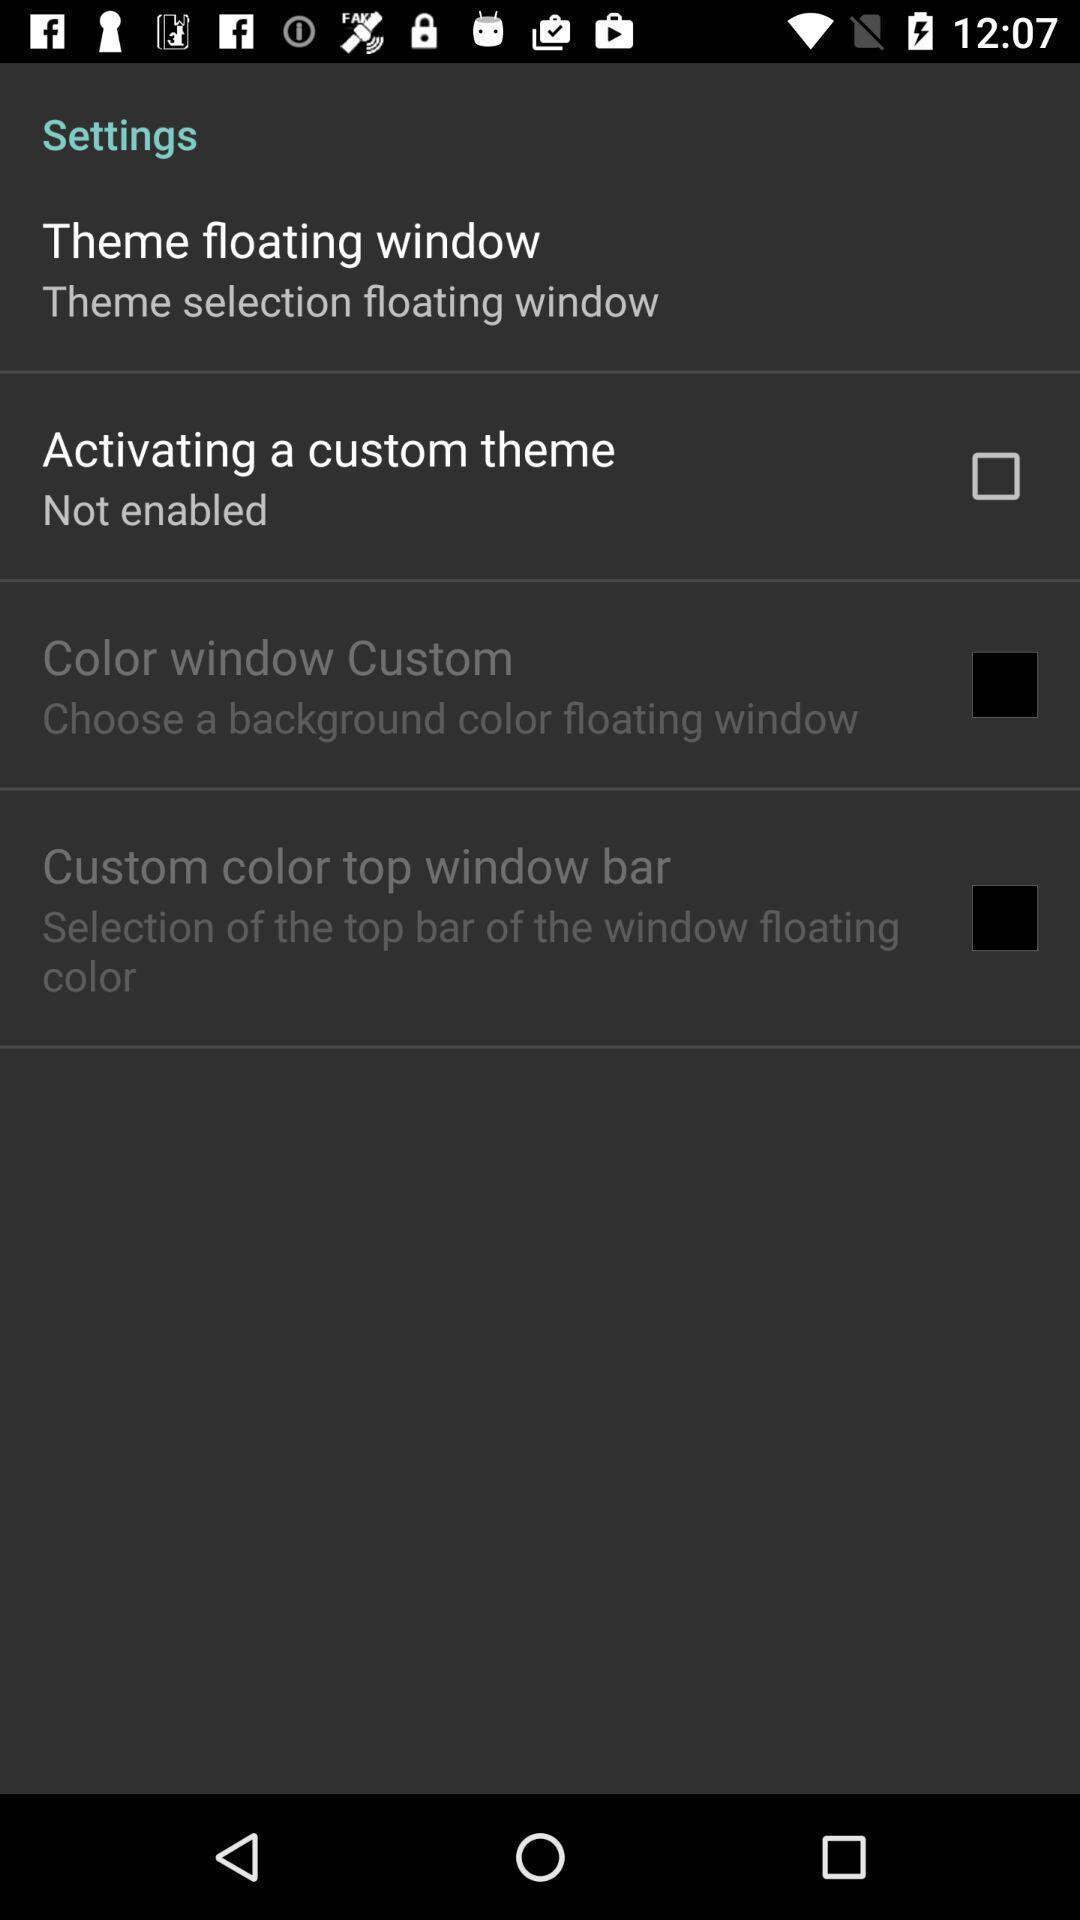Summarize the information in this screenshot. Settings page for activating a theme. 